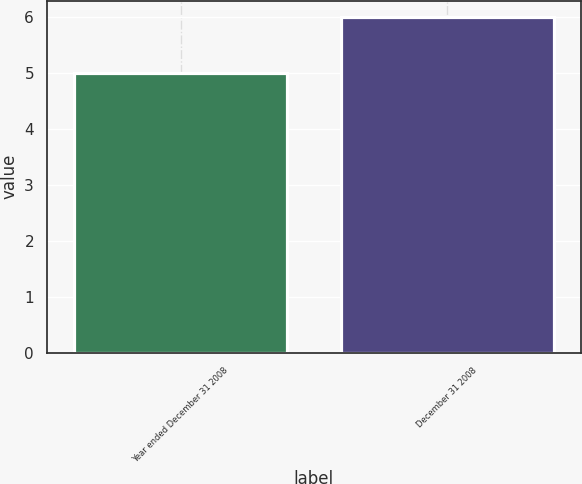Convert chart. <chart><loc_0><loc_0><loc_500><loc_500><bar_chart><fcel>Year ended December 31 2008<fcel>December 31 2008<nl><fcel>5<fcel>6<nl></chart> 